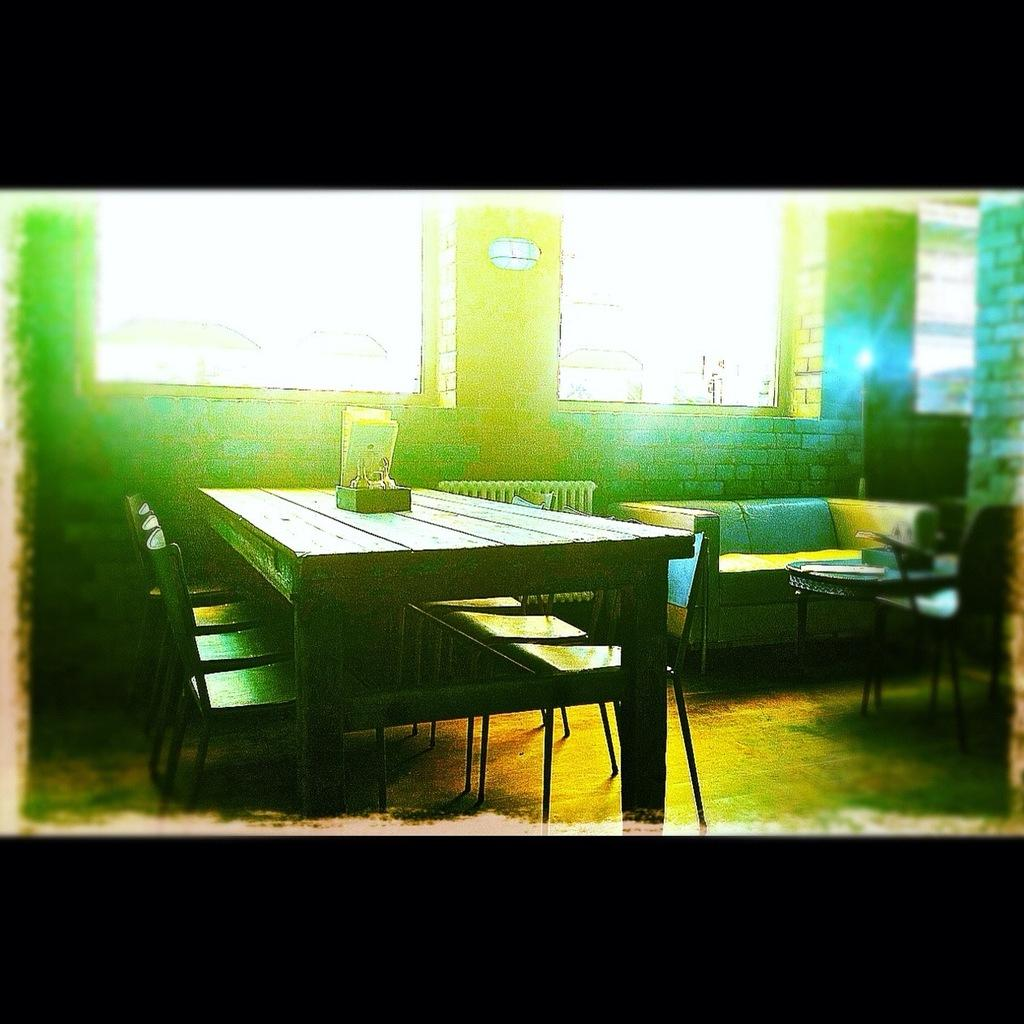What type of furniture is in the center of the image? There is a wooden table in the image. How are the chairs arranged in relation to the table? The chairs are arranged around the table. What piece of furniture is located on the top right of the image? There is a sofa on the top right of the image. What feature allows natural light to enter the room? There is a glass window in the image. What type of floor can be seen in the image? The provided facts do not mention the floor, so we cannot determine its type from the image. How many matches are on the table in the image? There are no matches present in the image. 